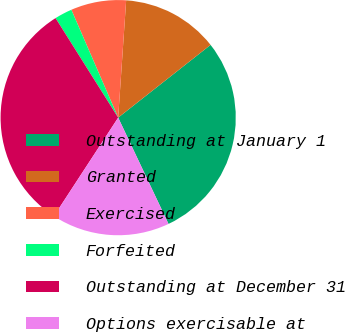Convert chart to OTSL. <chart><loc_0><loc_0><loc_500><loc_500><pie_chart><fcel>Outstanding at January 1<fcel>Granted<fcel>Exercised<fcel>Forfeited<fcel>Outstanding at December 31<fcel>Options exercisable at<nl><fcel>28.58%<fcel>13.3%<fcel>7.6%<fcel>2.42%<fcel>31.86%<fcel>16.24%<nl></chart> 